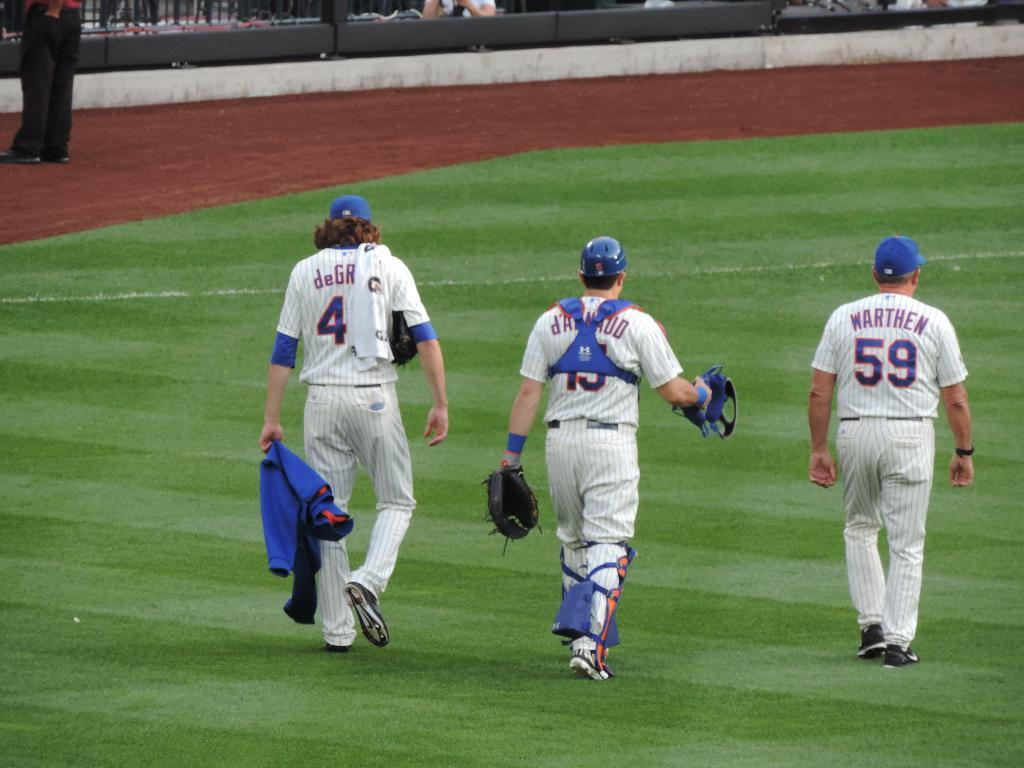<image>
Share a concise interpretation of the image provided. A man named Warthen walks alongside two fellow team members. 